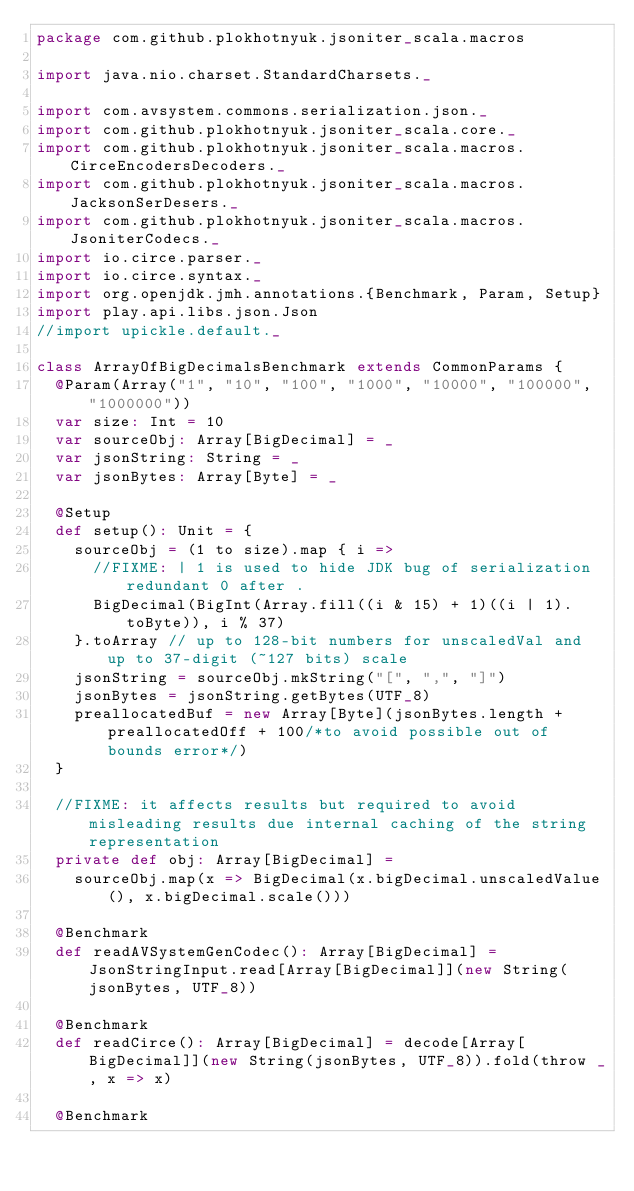<code> <loc_0><loc_0><loc_500><loc_500><_Scala_>package com.github.plokhotnyuk.jsoniter_scala.macros

import java.nio.charset.StandardCharsets._

import com.avsystem.commons.serialization.json._
import com.github.plokhotnyuk.jsoniter_scala.core._
import com.github.plokhotnyuk.jsoniter_scala.macros.CirceEncodersDecoders._
import com.github.plokhotnyuk.jsoniter_scala.macros.JacksonSerDesers._
import com.github.plokhotnyuk.jsoniter_scala.macros.JsoniterCodecs._
import io.circe.parser._
import io.circe.syntax._
import org.openjdk.jmh.annotations.{Benchmark, Param, Setup}
import play.api.libs.json.Json
//import upickle.default._

class ArrayOfBigDecimalsBenchmark extends CommonParams {
  @Param(Array("1", "10", "100", "1000", "10000", "100000", "1000000"))
  var size: Int = 10
  var sourceObj: Array[BigDecimal] = _
  var jsonString: String = _
  var jsonBytes: Array[Byte] = _

  @Setup
  def setup(): Unit = {
    sourceObj = (1 to size).map { i =>
      //FIXME: | 1 is used to hide JDK bug of serialization redundant 0 after .
      BigDecimal(BigInt(Array.fill((i & 15) + 1)((i | 1).toByte)), i % 37)
    }.toArray // up to 128-bit numbers for unscaledVal and up to 37-digit (~127 bits) scale
    jsonString = sourceObj.mkString("[", ",", "]")
    jsonBytes = jsonString.getBytes(UTF_8)
    preallocatedBuf = new Array[Byte](jsonBytes.length + preallocatedOff + 100/*to avoid possible out of bounds error*/)
  }

  //FIXME: it affects results but required to avoid misleading results due internal caching of the string representation
  private def obj: Array[BigDecimal] =
    sourceObj.map(x => BigDecimal(x.bigDecimal.unscaledValue(), x.bigDecimal.scale()))

  @Benchmark
  def readAVSystemGenCodec(): Array[BigDecimal] = JsonStringInput.read[Array[BigDecimal]](new String(jsonBytes, UTF_8))

  @Benchmark
  def readCirce(): Array[BigDecimal] = decode[Array[BigDecimal]](new String(jsonBytes, UTF_8)).fold(throw _, x => x)

  @Benchmark</code> 